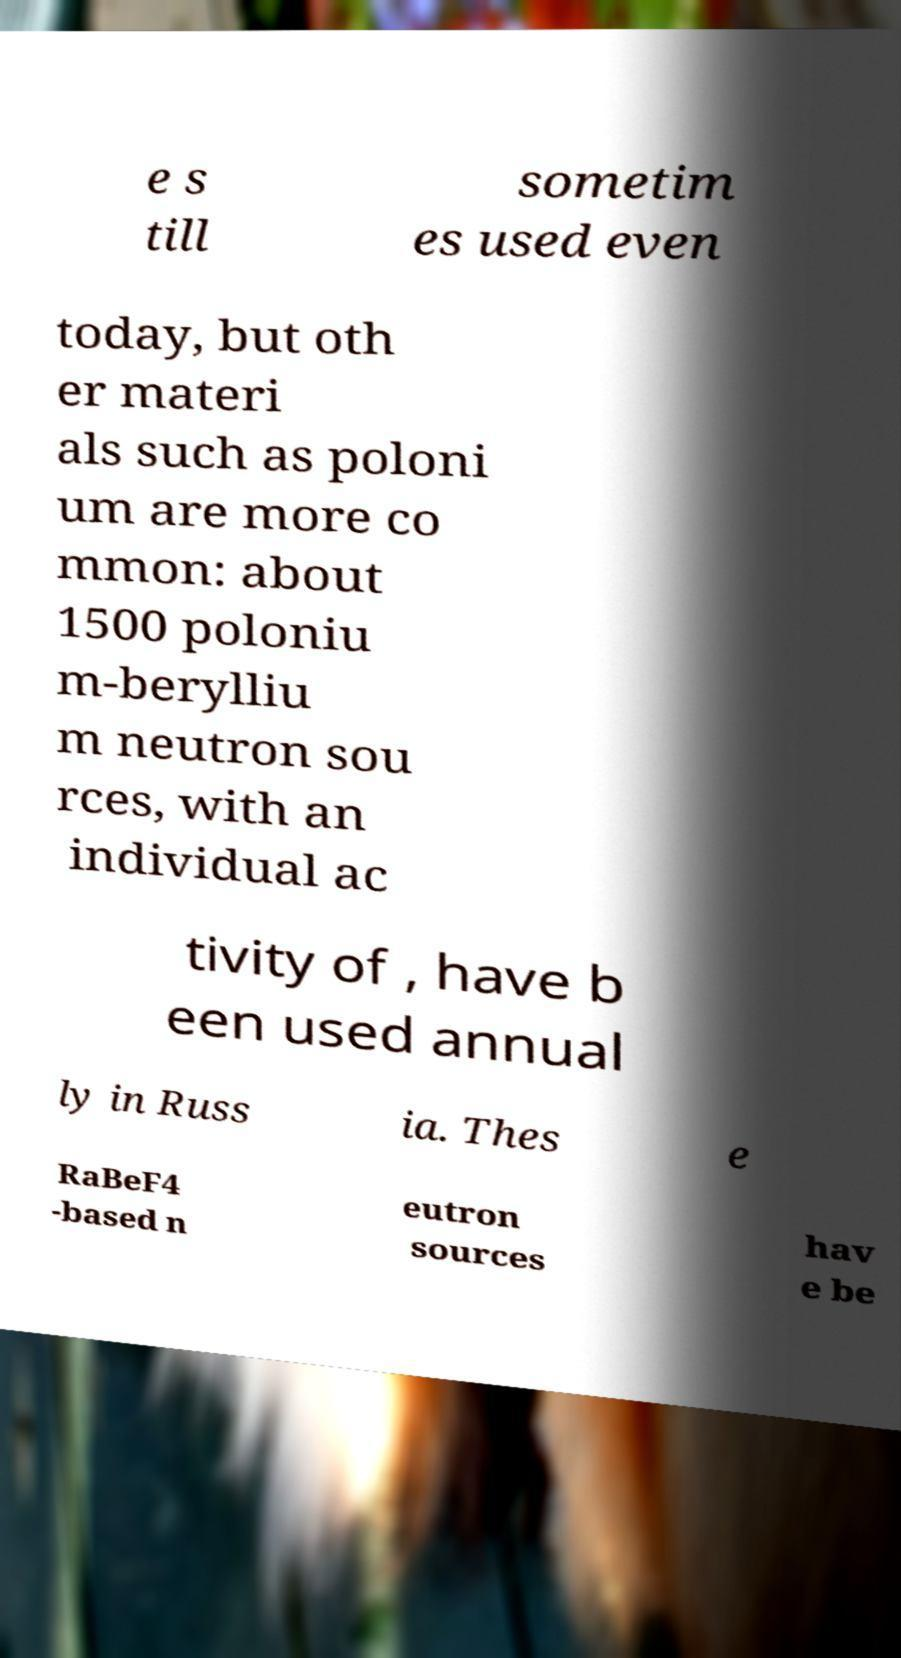I need the written content from this picture converted into text. Can you do that? e s till sometim es used even today, but oth er materi als such as poloni um are more co mmon: about 1500 poloniu m-berylliu m neutron sou rces, with an individual ac tivity of , have b een used annual ly in Russ ia. Thes e RaBeF4 -based n eutron sources hav e be 